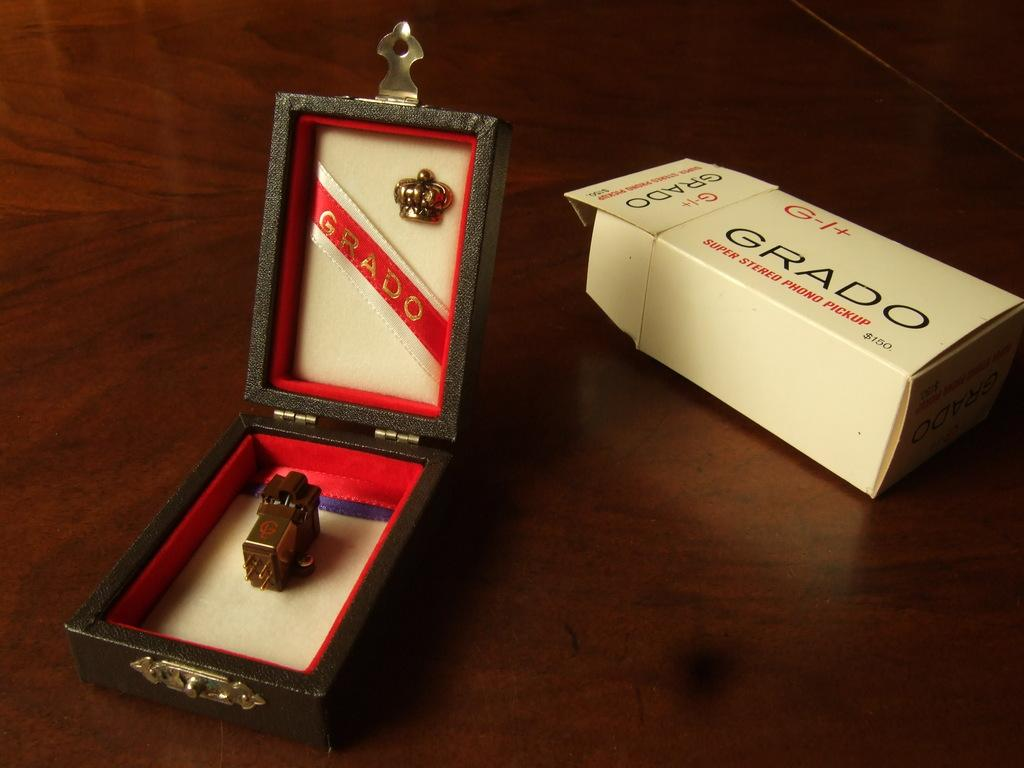<image>
Relay a brief, clear account of the picture shown. GRADO is the brand of the super stereo phono pickup. 